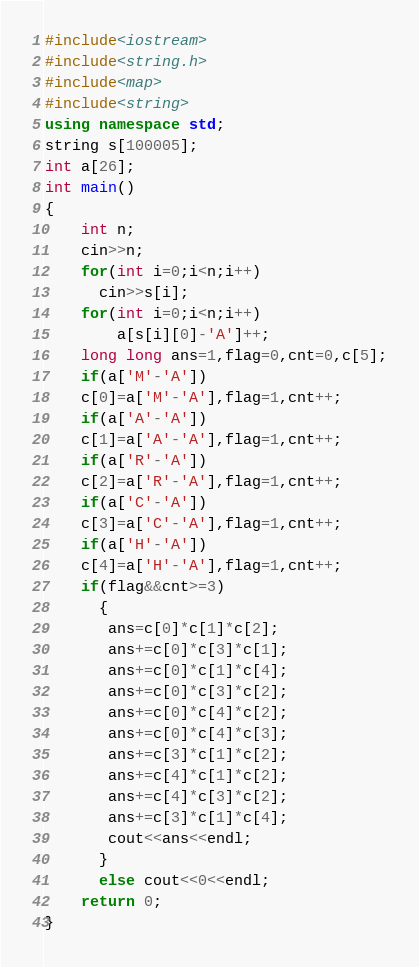<code> <loc_0><loc_0><loc_500><loc_500><_C++_>#include<iostream>
#include<string.h>
#include<map>
#include<string>
using namespace std;
string s[100005];
int a[26];
int main()
{
    int n;
    cin>>n;
    for(int i=0;i<n;i++)
      cin>>s[i];
    for(int i=0;i<n;i++)
        a[s[i][0]-'A']++;
    long long ans=1,flag=0,cnt=0,c[5];
    if(a['M'-'A'])
    c[0]=a['M'-'A'],flag=1,cnt++;
    if(a['A'-'A'])
    c[1]=a['A'-'A'],flag=1,cnt++;
    if(a['R'-'A'])
    c[2]=a['R'-'A'],flag=1,cnt++;
    if(a['C'-'A'])
    c[3]=a['C'-'A'],flag=1,cnt++;
    if(a['H'-'A'])
    c[4]=a['H'-'A'],flag=1,cnt++;
    if(flag&&cnt>=3)
      {
       ans=c[0]*c[1]*c[2];
       ans+=c[0]*c[3]*c[1];
       ans+=c[0]*c[1]*c[4];
       ans+=c[0]*c[3]*c[2];
       ans+=c[0]*c[4]*c[2];
       ans+=c[0]*c[4]*c[3];
       ans+=c[3]*c[1]*c[2];
       ans+=c[4]*c[1]*c[2];
       ans+=c[4]*c[3]*c[2];
       ans+=c[3]*c[1]*c[4];
       cout<<ans<<endl;
      }
      else cout<<0<<endl;
    return 0;
}</code> 